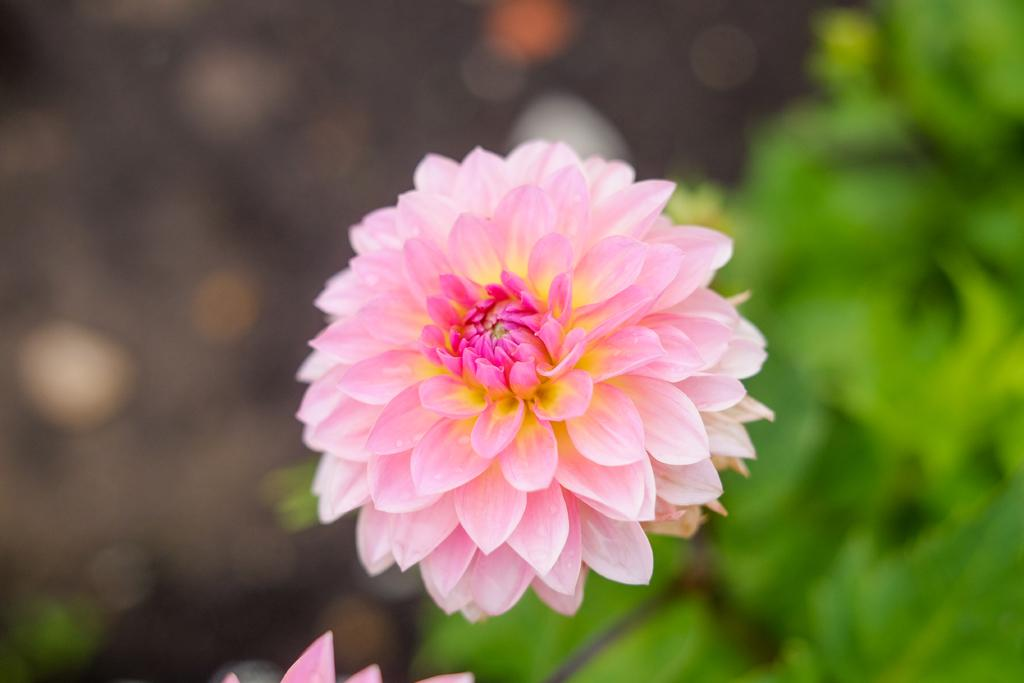What is the main subject of the image? There is a flower in the image. Can you describe the flower in more detail? The flower has petals. What can be observed about the background of the image? The background of the image is blurred. What type of substance can be seen on the petals of the flower in the image? There is no substance visible on the petals of the flower in the image. Is there any dirt visible on the flower in the image? There is no dirt visible on the flower in the image. 